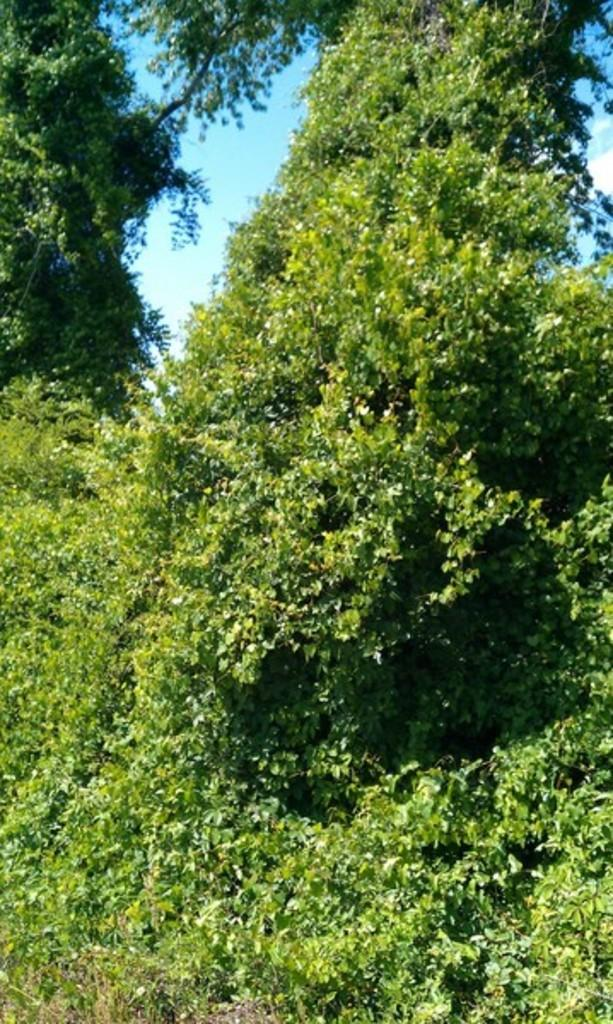What can be seen in the background of the image? The sky is visible in the image. What is present in the sky? Clouds are present in the image. What type of vegetation can be seen in the image? Trees are in the image. What type of church can be seen in the image? There is no church present in the image; it features the sky, clouds, and trees. What force is being applied to the trees in the image? There is no force being applied to the trees in the image; they are stationary. 